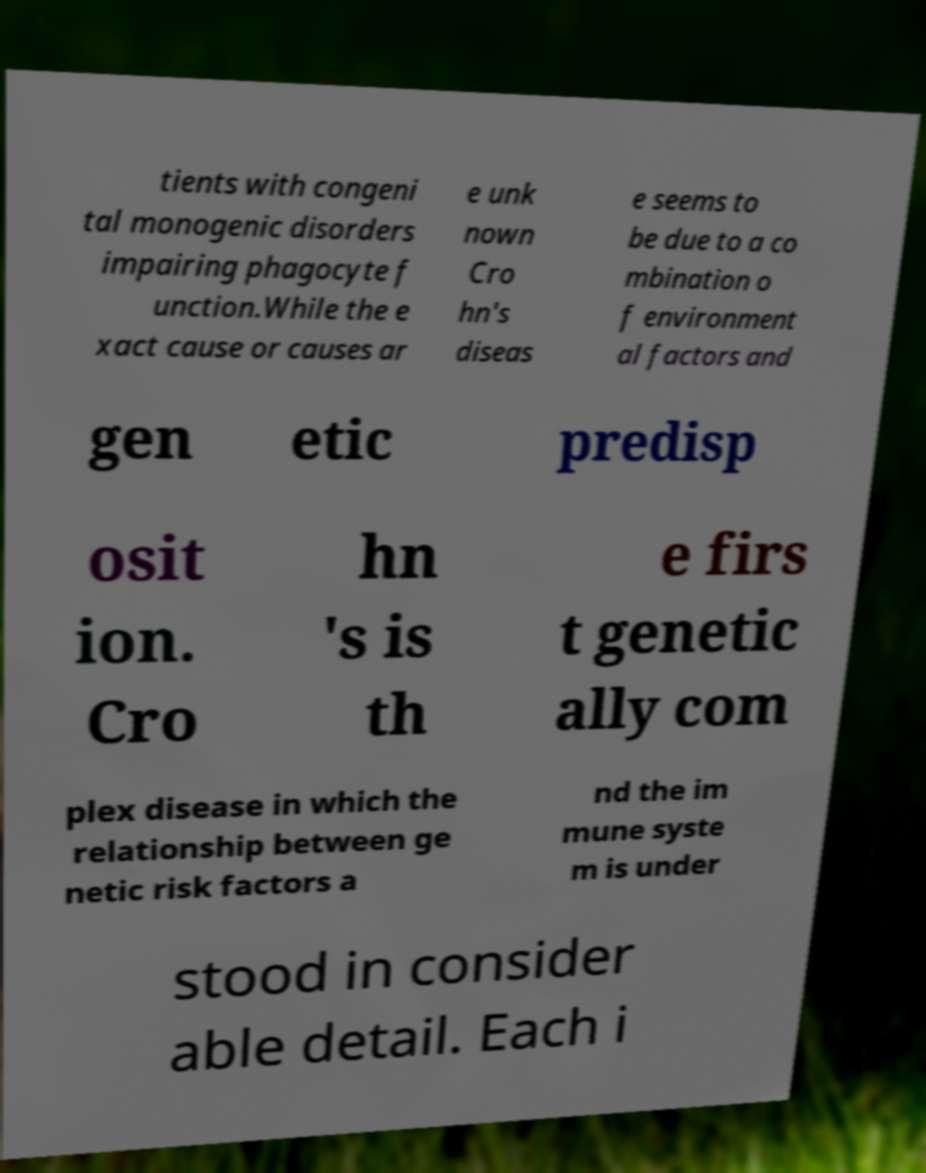There's text embedded in this image that I need extracted. Can you transcribe it verbatim? tients with congeni tal monogenic disorders impairing phagocyte f unction.While the e xact cause or causes ar e unk nown Cro hn's diseas e seems to be due to a co mbination o f environment al factors and gen etic predisp osit ion. Cro hn 's is th e firs t genetic ally com plex disease in which the relationship between ge netic risk factors a nd the im mune syste m is under stood in consider able detail. Each i 